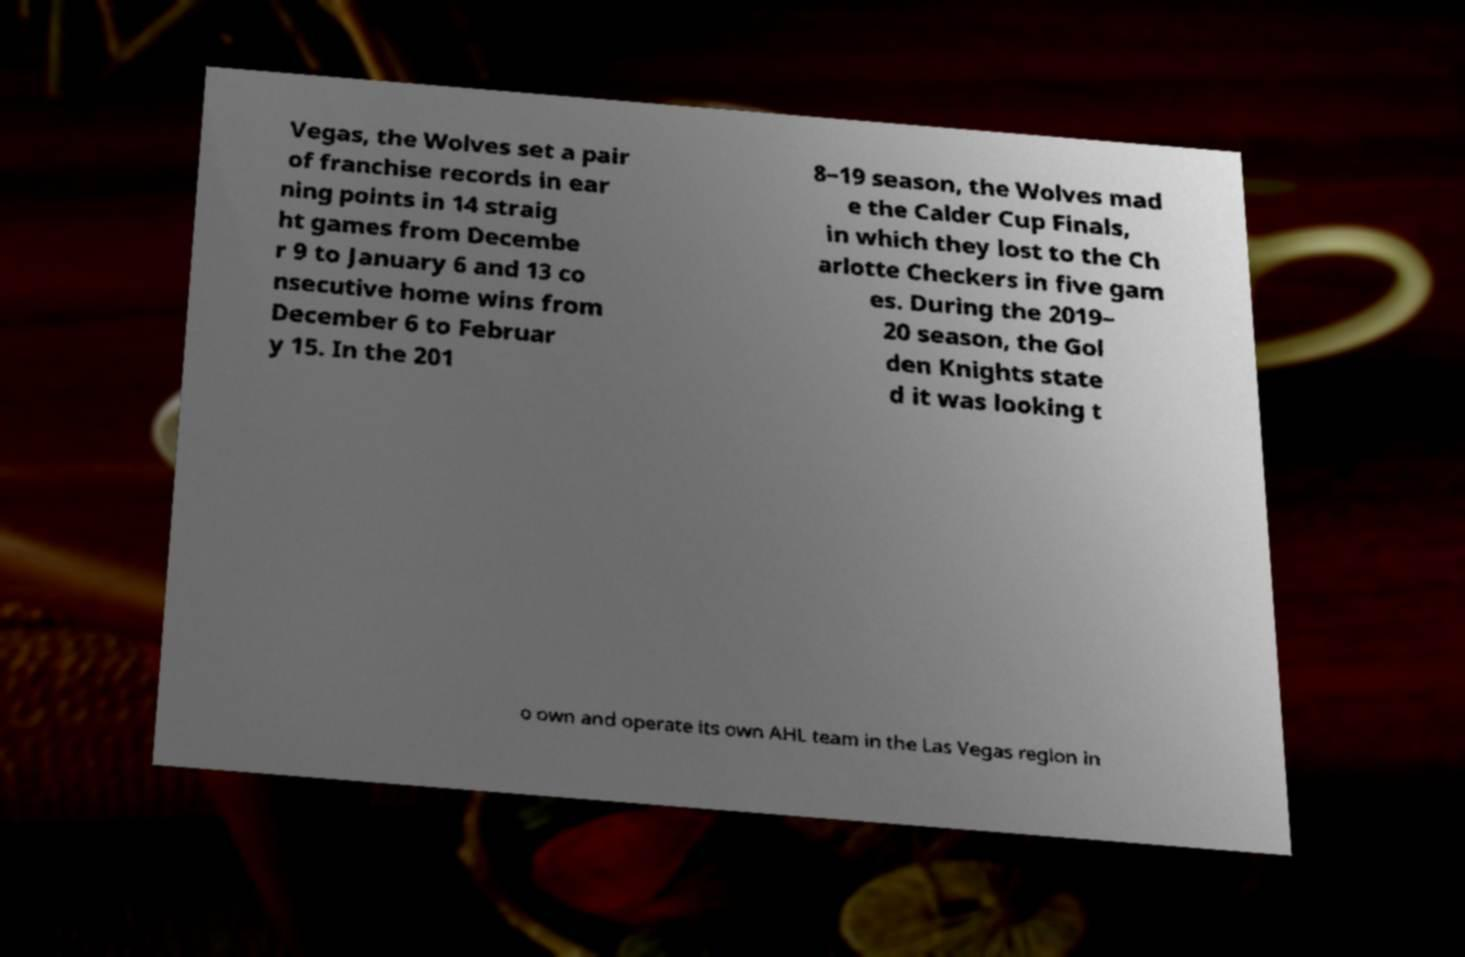There's text embedded in this image that I need extracted. Can you transcribe it verbatim? Vegas, the Wolves set a pair of franchise records in ear ning points in 14 straig ht games from Decembe r 9 to January 6 and 13 co nsecutive home wins from December 6 to Februar y 15. In the 201 8–19 season, the Wolves mad e the Calder Cup Finals, in which they lost to the Ch arlotte Checkers in five gam es. During the 2019– 20 season, the Gol den Knights state d it was looking t o own and operate its own AHL team in the Las Vegas region in 